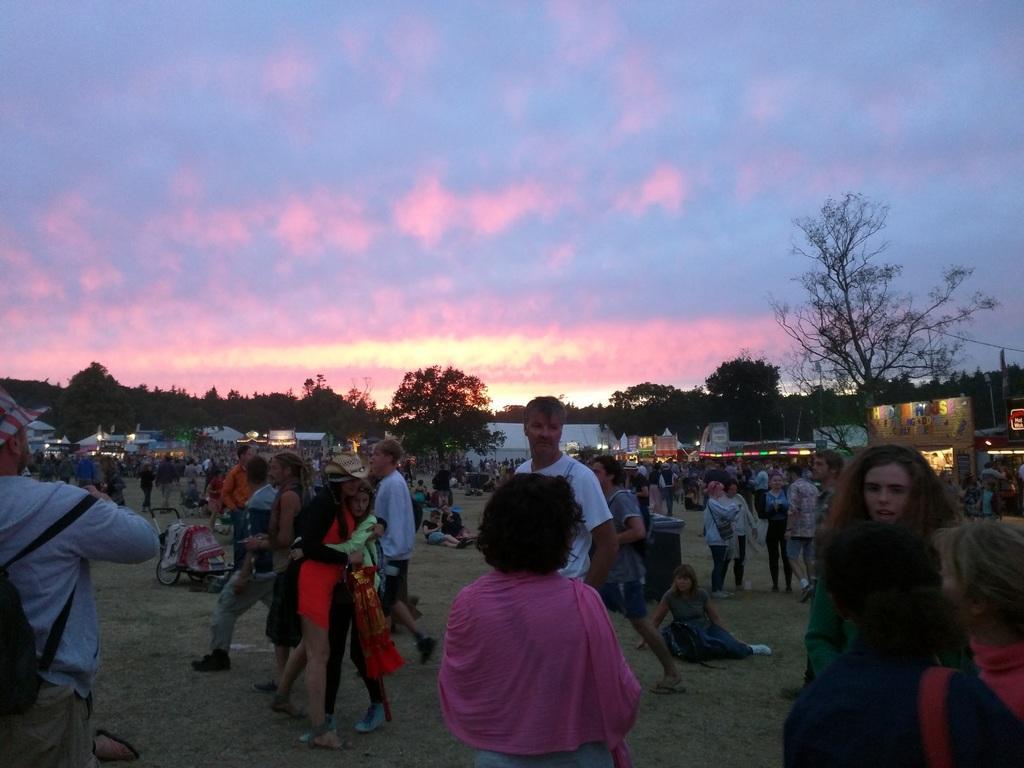Please provide a concise description of this image. In this image we can see a group of persons are standing on the ground, and some are sitting, here are the trees, here is the light, at above here is the sky. 